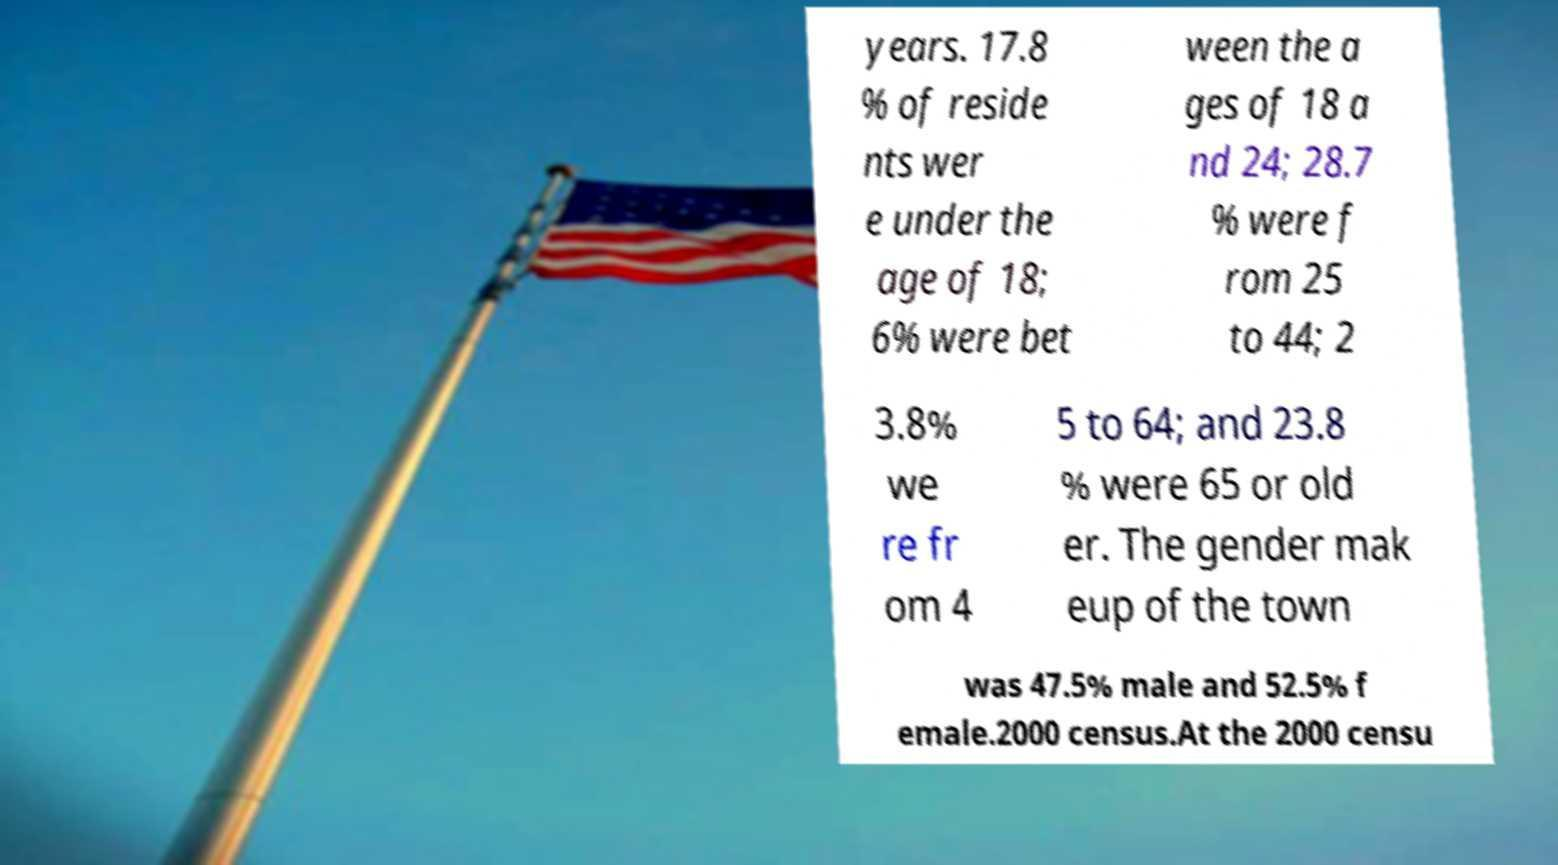Please identify and transcribe the text found in this image. years. 17.8 % of reside nts wer e under the age of 18; 6% were bet ween the a ges of 18 a nd 24; 28.7 % were f rom 25 to 44; 2 3.8% we re fr om 4 5 to 64; and 23.8 % were 65 or old er. The gender mak eup of the town was 47.5% male and 52.5% f emale.2000 census.At the 2000 censu 